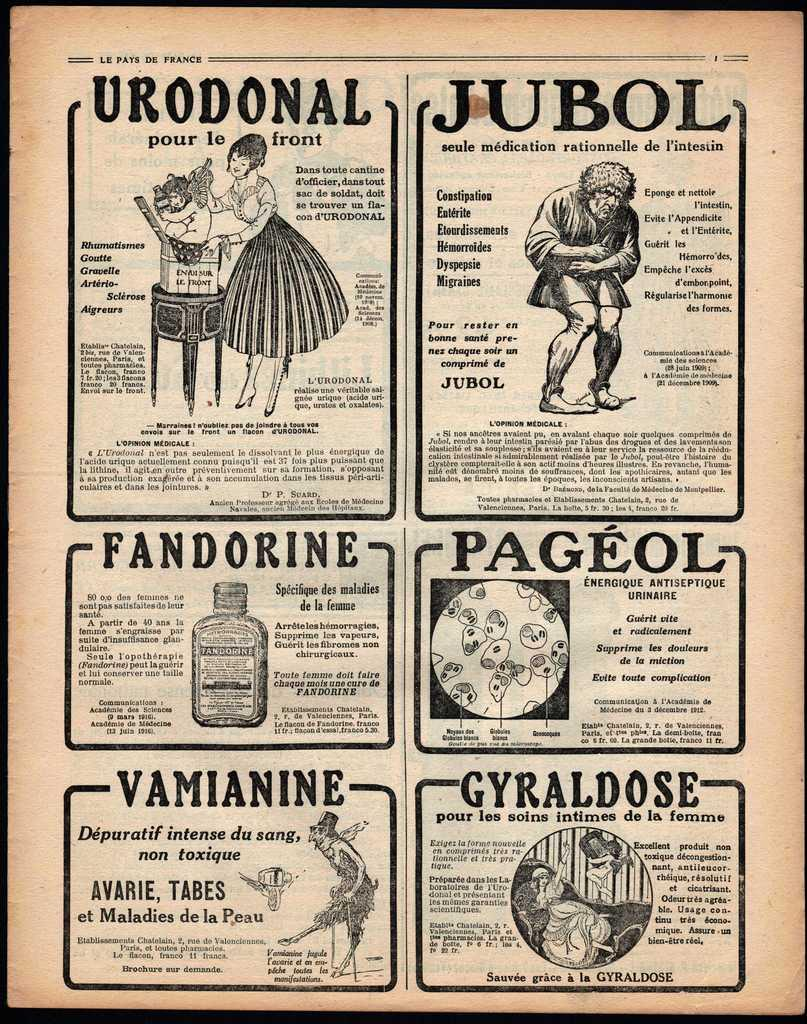What is the main subject of the paper in the image? The main subject of the paper in the image is a scene that includes a man, a woman, a table, a box, and a bottle. Can you describe the scene depicted on the paper? The scene on the paper features a man and a woman, who are likely interacting with each other, as well as a table, a box, and a bottle. Is there any text present on the paper? Yes, there is writing on the paper. What type of flame can be seen coming from the box in the image? There is no flame present in the image; the box is depicted on the paper as part of the scene. What operation is being performed on the table in the image? There is no operation being performed on the table in the image; it is simply depicted as part of the scene. 